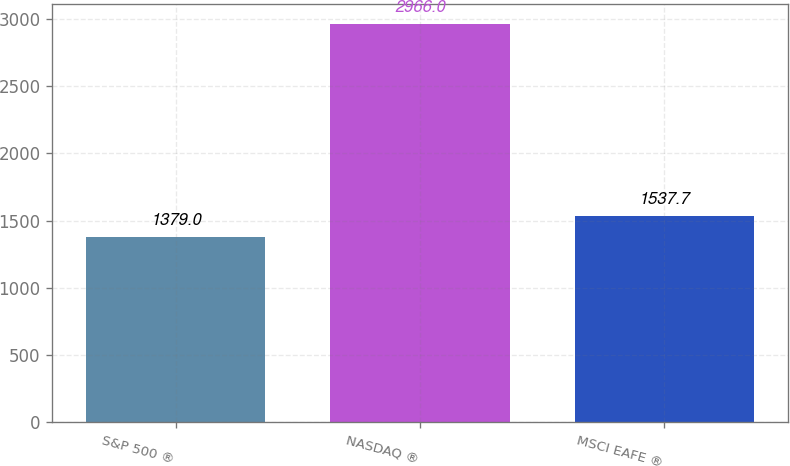Convert chart. <chart><loc_0><loc_0><loc_500><loc_500><bar_chart><fcel>S&P 500 ®<fcel>NASDAQ ®<fcel>MSCI EAFE ®<nl><fcel>1379<fcel>2966<fcel>1537.7<nl></chart> 